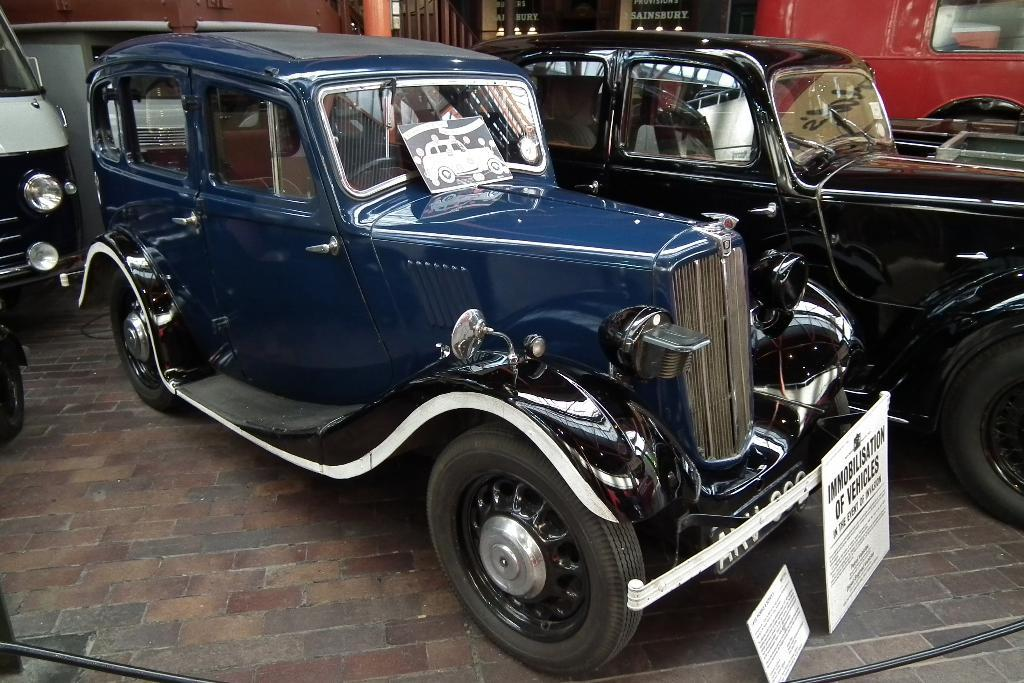What type of vehicles are present on the ground in the image? There are cars on the ground in the image. What features do the cars have? The cars have windshields, steering wheels, doors, tires, and name plates. Can you describe the windshields on the cars? The windshields are transparent and allow the driver to see the road ahead. What part of the car is used for steering? The cars have steering wheels, which are used for steering the vehicle. Can you tell me how many sweaters are hanging on the seashore in the image? There is no seashore or sweater present in the image; it features cars on the ground. What type of fiction is being read by the driver of the car in the image? There is no indication in the image that anyone is reading fiction or that there is any fiction present. 